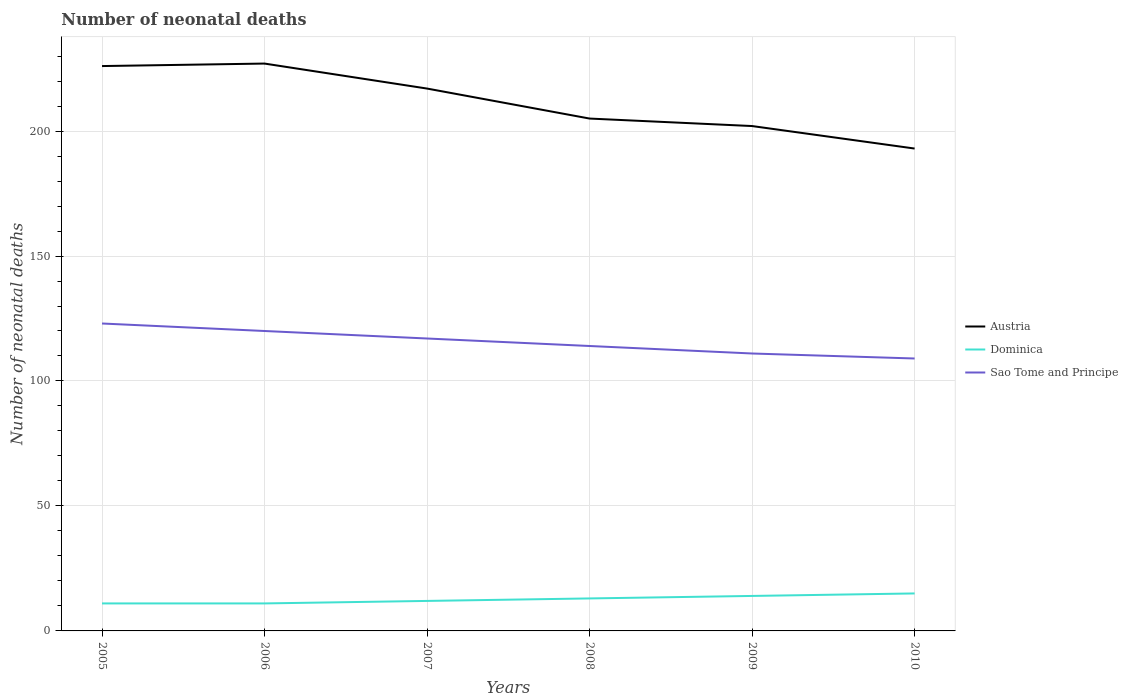Across all years, what is the maximum number of neonatal deaths in in Sao Tome and Principe?
Your answer should be compact. 109. In which year was the number of neonatal deaths in in Sao Tome and Principe maximum?
Offer a terse response. 2010. What is the total number of neonatal deaths in in Austria in the graph?
Your answer should be compact. 24. What is the difference between the highest and the second highest number of neonatal deaths in in Austria?
Your answer should be compact. 34. How many lines are there?
Your response must be concise. 3. How are the legend labels stacked?
Offer a very short reply. Vertical. What is the title of the graph?
Your answer should be very brief. Number of neonatal deaths. What is the label or title of the X-axis?
Keep it short and to the point. Years. What is the label or title of the Y-axis?
Your answer should be compact. Number of neonatal deaths. What is the Number of neonatal deaths in Austria in 2005?
Provide a short and direct response. 226. What is the Number of neonatal deaths of Sao Tome and Principe in 2005?
Your response must be concise. 123. What is the Number of neonatal deaths in Austria in 2006?
Provide a succinct answer. 227. What is the Number of neonatal deaths in Sao Tome and Principe in 2006?
Give a very brief answer. 120. What is the Number of neonatal deaths in Austria in 2007?
Make the answer very short. 217. What is the Number of neonatal deaths of Dominica in 2007?
Give a very brief answer. 12. What is the Number of neonatal deaths in Sao Tome and Principe in 2007?
Offer a terse response. 117. What is the Number of neonatal deaths of Austria in 2008?
Keep it short and to the point. 205. What is the Number of neonatal deaths in Sao Tome and Principe in 2008?
Your answer should be very brief. 114. What is the Number of neonatal deaths of Austria in 2009?
Provide a short and direct response. 202. What is the Number of neonatal deaths in Dominica in 2009?
Keep it short and to the point. 14. What is the Number of neonatal deaths of Sao Tome and Principe in 2009?
Offer a terse response. 111. What is the Number of neonatal deaths of Austria in 2010?
Ensure brevity in your answer.  193. What is the Number of neonatal deaths of Dominica in 2010?
Give a very brief answer. 15. What is the Number of neonatal deaths of Sao Tome and Principe in 2010?
Provide a succinct answer. 109. Across all years, what is the maximum Number of neonatal deaths of Austria?
Give a very brief answer. 227. Across all years, what is the maximum Number of neonatal deaths of Dominica?
Offer a terse response. 15. Across all years, what is the maximum Number of neonatal deaths of Sao Tome and Principe?
Ensure brevity in your answer.  123. Across all years, what is the minimum Number of neonatal deaths of Austria?
Make the answer very short. 193. Across all years, what is the minimum Number of neonatal deaths of Sao Tome and Principe?
Keep it short and to the point. 109. What is the total Number of neonatal deaths in Austria in the graph?
Offer a very short reply. 1270. What is the total Number of neonatal deaths of Dominica in the graph?
Offer a terse response. 76. What is the total Number of neonatal deaths in Sao Tome and Principe in the graph?
Provide a short and direct response. 694. What is the difference between the Number of neonatal deaths in Austria in 2005 and that in 2006?
Make the answer very short. -1. What is the difference between the Number of neonatal deaths in Dominica in 2005 and that in 2006?
Your answer should be very brief. 0. What is the difference between the Number of neonatal deaths in Sao Tome and Principe in 2005 and that in 2006?
Provide a short and direct response. 3. What is the difference between the Number of neonatal deaths in Austria in 2005 and that in 2007?
Provide a succinct answer. 9. What is the difference between the Number of neonatal deaths of Austria in 2005 and that in 2008?
Your answer should be compact. 21. What is the difference between the Number of neonatal deaths of Dominica in 2005 and that in 2008?
Offer a very short reply. -2. What is the difference between the Number of neonatal deaths in Sao Tome and Principe in 2005 and that in 2009?
Your answer should be compact. 12. What is the difference between the Number of neonatal deaths in Austria in 2005 and that in 2010?
Provide a short and direct response. 33. What is the difference between the Number of neonatal deaths of Dominica in 2005 and that in 2010?
Make the answer very short. -4. What is the difference between the Number of neonatal deaths in Sao Tome and Principe in 2005 and that in 2010?
Make the answer very short. 14. What is the difference between the Number of neonatal deaths of Austria in 2006 and that in 2008?
Your answer should be very brief. 22. What is the difference between the Number of neonatal deaths of Austria in 2006 and that in 2010?
Offer a very short reply. 34. What is the difference between the Number of neonatal deaths in Austria in 2007 and that in 2009?
Provide a succinct answer. 15. What is the difference between the Number of neonatal deaths of Sao Tome and Principe in 2007 and that in 2009?
Provide a short and direct response. 6. What is the difference between the Number of neonatal deaths in Dominica in 2007 and that in 2010?
Ensure brevity in your answer.  -3. What is the difference between the Number of neonatal deaths in Dominica in 2008 and that in 2009?
Ensure brevity in your answer.  -1. What is the difference between the Number of neonatal deaths in Austria in 2008 and that in 2010?
Ensure brevity in your answer.  12. What is the difference between the Number of neonatal deaths of Sao Tome and Principe in 2008 and that in 2010?
Keep it short and to the point. 5. What is the difference between the Number of neonatal deaths in Sao Tome and Principe in 2009 and that in 2010?
Offer a terse response. 2. What is the difference between the Number of neonatal deaths in Austria in 2005 and the Number of neonatal deaths in Dominica in 2006?
Offer a terse response. 215. What is the difference between the Number of neonatal deaths in Austria in 2005 and the Number of neonatal deaths in Sao Tome and Principe in 2006?
Offer a terse response. 106. What is the difference between the Number of neonatal deaths of Dominica in 2005 and the Number of neonatal deaths of Sao Tome and Principe in 2006?
Keep it short and to the point. -109. What is the difference between the Number of neonatal deaths of Austria in 2005 and the Number of neonatal deaths of Dominica in 2007?
Your answer should be very brief. 214. What is the difference between the Number of neonatal deaths of Austria in 2005 and the Number of neonatal deaths of Sao Tome and Principe in 2007?
Keep it short and to the point. 109. What is the difference between the Number of neonatal deaths of Dominica in 2005 and the Number of neonatal deaths of Sao Tome and Principe in 2007?
Offer a very short reply. -106. What is the difference between the Number of neonatal deaths of Austria in 2005 and the Number of neonatal deaths of Dominica in 2008?
Make the answer very short. 213. What is the difference between the Number of neonatal deaths of Austria in 2005 and the Number of neonatal deaths of Sao Tome and Principe in 2008?
Offer a very short reply. 112. What is the difference between the Number of neonatal deaths of Dominica in 2005 and the Number of neonatal deaths of Sao Tome and Principe in 2008?
Provide a succinct answer. -103. What is the difference between the Number of neonatal deaths of Austria in 2005 and the Number of neonatal deaths of Dominica in 2009?
Your answer should be very brief. 212. What is the difference between the Number of neonatal deaths in Austria in 2005 and the Number of neonatal deaths in Sao Tome and Principe in 2009?
Offer a very short reply. 115. What is the difference between the Number of neonatal deaths of Dominica in 2005 and the Number of neonatal deaths of Sao Tome and Principe in 2009?
Your response must be concise. -100. What is the difference between the Number of neonatal deaths of Austria in 2005 and the Number of neonatal deaths of Dominica in 2010?
Your answer should be compact. 211. What is the difference between the Number of neonatal deaths of Austria in 2005 and the Number of neonatal deaths of Sao Tome and Principe in 2010?
Your answer should be very brief. 117. What is the difference between the Number of neonatal deaths of Dominica in 2005 and the Number of neonatal deaths of Sao Tome and Principe in 2010?
Provide a succinct answer. -98. What is the difference between the Number of neonatal deaths in Austria in 2006 and the Number of neonatal deaths in Dominica in 2007?
Offer a terse response. 215. What is the difference between the Number of neonatal deaths in Austria in 2006 and the Number of neonatal deaths in Sao Tome and Principe in 2007?
Make the answer very short. 110. What is the difference between the Number of neonatal deaths of Dominica in 2006 and the Number of neonatal deaths of Sao Tome and Principe in 2007?
Offer a terse response. -106. What is the difference between the Number of neonatal deaths of Austria in 2006 and the Number of neonatal deaths of Dominica in 2008?
Keep it short and to the point. 214. What is the difference between the Number of neonatal deaths in Austria in 2006 and the Number of neonatal deaths in Sao Tome and Principe in 2008?
Make the answer very short. 113. What is the difference between the Number of neonatal deaths of Dominica in 2006 and the Number of neonatal deaths of Sao Tome and Principe in 2008?
Offer a very short reply. -103. What is the difference between the Number of neonatal deaths of Austria in 2006 and the Number of neonatal deaths of Dominica in 2009?
Offer a very short reply. 213. What is the difference between the Number of neonatal deaths in Austria in 2006 and the Number of neonatal deaths in Sao Tome and Principe in 2009?
Offer a very short reply. 116. What is the difference between the Number of neonatal deaths in Dominica in 2006 and the Number of neonatal deaths in Sao Tome and Principe in 2009?
Make the answer very short. -100. What is the difference between the Number of neonatal deaths of Austria in 2006 and the Number of neonatal deaths of Dominica in 2010?
Your response must be concise. 212. What is the difference between the Number of neonatal deaths of Austria in 2006 and the Number of neonatal deaths of Sao Tome and Principe in 2010?
Your response must be concise. 118. What is the difference between the Number of neonatal deaths in Dominica in 2006 and the Number of neonatal deaths in Sao Tome and Principe in 2010?
Offer a terse response. -98. What is the difference between the Number of neonatal deaths in Austria in 2007 and the Number of neonatal deaths in Dominica in 2008?
Give a very brief answer. 204. What is the difference between the Number of neonatal deaths of Austria in 2007 and the Number of neonatal deaths of Sao Tome and Principe in 2008?
Keep it short and to the point. 103. What is the difference between the Number of neonatal deaths in Dominica in 2007 and the Number of neonatal deaths in Sao Tome and Principe in 2008?
Provide a short and direct response. -102. What is the difference between the Number of neonatal deaths in Austria in 2007 and the Number of neonatal deaths in Dominica in 2009?
Your response must be concise. 203. What is the difference between the Number of neonatal deaths of Austria in 2007 and the Number of neonatal deaths of Sao Tome and Principe in 2009?
Your answer should be very brief. 106. What is the difference between the Number of neonatal deaths of Dominica in 2007 and the Number of neonatal deaths of Sao Tome and Principe in 2009?
Give a very brief answer. -99. What is the difference between the Number of neonatal deaths in Austria in 2007 and the Number of neonatal deaths in Dominica in 2010?
Provide a short and direct response. 202. What is the difference between the Number of neonatal deaths of Austria in 2007 and the Number of neonatal deaths of Sao Tome and Principe in 2010?
Your answer should be very brief. 108. What is the difference between the Number of neonatal deaths in Dominica in 2007 and the Number of neonatal deaths in Sao Tome and Principe in 2010?
Your answer should be very brief. -97. What is the difference between the Number of neonatal deaths of Austria in 2008 and the Number of neonatal deaths of Dominica in 2009?
Give a very brief answer. 191. What is the difference between the Number of neonatal deaths of Austria in 2008 and the Number of neonatal deaths of Sao Tome and Principe in 2009?
Offer a terse response. 94. What is the difference between the Number of neonatal deaths of Dominica in 2008 and the Number of neonatal deaths of Sao Tome and Principe in 2009?
Your response must be concise. -98. What is the difference between the Number of neonatal deaths of Austria in 2008 and the Number of neonatal deaths of Dominica in 2010?
Your response must be concise. 190. What is the difference between the Number of neonatal deaths of Austria in 2008 and the Number of neonatal deaths of Sao Tome and Principe in 2010?
Ensure brevity in your answer.  96. What is the difference between the Number of neonatal deaths in Dominica in 2008 and the Number of neonatal deaths in Sao Tome and Principe in 2010?
Offer a terse response. -96. What is the difference between the Number of neonatal deaths of Austria in 2009 and the Number of neonatal deaths of Dominica in 2010?
Make the answer very short. 187. What is the difference between the Number of neonatal deaths of Austria in 2009 and the Number of neonatal deaths of Sao Tome and Principe in 2010?
Ensure brevity in your answer.  93. What is the difference between the Number of neonatal deaths of Dominica in 2009 and the Number of neonatal deaths of Sao Tome and Principe in 2010?
Your response must be concise. -95. What is the average Number of neonatal deaths of Austria per year?
Offer a terse response. 211.67. What is the average Number of neonatal deaths in Dominica per year?
Your response must be concise. 12.67. What is the average Number of neonatal deaths of Sao Tome and Principe per year?
Keep it short and to the point. 115.67. In the year 2005, what is the difference between the Number of neonatal deaths of Austria and Number of neonatal deaths of Dominica?
Keep it short and to the point. 215. In the year 2005, what is the difference between the Number of neonatal deaths of Austria and Number of neonatal deaths of Sao Tome and Principe?
Offer a terse response. 103. In the year 2005, what is the difference between the Number of neonatal deaths in Dominica and Number of neonatal deaths in Sao Tome and Principe?
Offer a very short reply. -112. In the year 2006, what is the difference between the Number of neonatal deaths of Austria and Number of neonatal deaths of Dominica?
Your response must be concise. 216. In the year 2006, what is the difference between the Number of neonatal deaths of Austria and Number of neonatal deaths of Sao Tome and Principe?
Give a very brief answer. 107. In the year 2006, what is the difference between the Number of neonatal deaths of Dominica and Number of neonatal deaths of Sao Tome and Principe?
Give a very brief answer. -109. In the year 2007, what is the difference between the Number of neonatal deaths of Austria and Number of neonatal deaths of Dominica?
Your response must be concise. 205. In the year 2007, what is the difference between the Number of neonatal deaths of Dominica and Number of neonatal deaths of Sao Tome and Principe?
Make the answer very short. -105. In the year 2008, what is the difference between the Number of neonatal deaths in Austria and Number of neonatal deaths in Dominica?
Your answer should be very brief. 192. In the year 2008, what is the difference between the Number of neonatal deaths in Austria and Number of neonatal deaths in Sao Tome and Principe?
Provide a short and direct response. 91. In the year 2008, what is the difference between the Number of neonatal deaths in Dominica and Number of neonatal deaths in Sao Tome and Principe?
Offer a very short reply. -101. In the year 2009, what is the difference between the Number of neonatal deaths of Austria and Number of neonatal deaths of Dominica?
Provide a short and direct response. 188. In the year 2009, what is the difference between the Number of neonatal deaths in Austria and Number of neonatal deaths in Sao Tome and Principe?
Your answer should be very brief. 91. In the year 2009, what is the difference between the Number of neonatal deaths in Dominica and Number of neonatal deaths in Sao Tome and Principe?
Make the answer very short. -97. In the year 2010, what is the difference between the Number of neonatal deaths in Austria and Number of neonatal deaths in Dominica?
Ensure brevity in your answer.  178. In the year 2010, what is the difference between the Number of neonatal deaths of Dominica and Number of neonatal deaths of Sao Tome and Principe?
Ensure brevity in your answer.  -94. What is the ratio of the Number of neonatal deaths of Sao Tome and Principe in 2005 to that in 2006?
Provide a succinct answer. 1.02. What is the ratio of the Number of neonatal deaths in Austria in 2005 to that in 2007?
Your response must be concise. 1.04. What is the ratio of the Number of neonatal deaths in Sao Tome and Principe in 2005 to that in 2007?
Give a very brief answer. 1.05. What is the ratio of the Number of neonatal deaths of Austria in 2005 to that in 2008?
Give a very brief answer. 1.1. What is the ratio of the Number of neonatal deaths in Dominica in 2005 to that in 2008?
Offer a terse response. 0.85. What is the ratio of the Number of neonatal deaths of Sao Tome and Principe in 2005 to that in 2008?
Your response must be concise. 1.08. What is the ratio of the Number of neonatal deaths in Austria in 2005 to that in 2009?
Ensure brevity in your answer.  1.12. What is the ratio of the Number of neonatal deaths in Dominica in 2005 to that in 2009?
Your response must be concise. 0.79. What is the ratio of the Number of neonatal deaths in Sao Tome and Principe in 2005 to that in 2009?
Provide a succinct answer. 1.11. What is the ratio of the Number of neonatal deaths of Austria in 2005 to that in 2010?
Give a very brief answer. 1.17. What is the ratio of the Number of neonatal deaths of Dominica in 2005 to that in 2010?
Offer a terse response. 0.73. What is the ratio of the Number of neonatal deaths of Sao Tome and Principe in 2005 to that in 2010?
Your answer should be very brief. 1.13. What is the ratio of the Number of neonatal deaths of Austria in 2006 to that in 2007?
Provide a succinct answer. 1.05. What is the ratio of the Number of neonatal deaths in Sao Tome and Principe in 2006 to that in 2007?
Give a very brief answer. 1.03. What is the ratio of the Number of neonatal deaths of Austria in 2006 to that in 2008?
Keep it short and to the point. 1.11. What is the ratio of the Number of neonatal deaths of Dominica in 2006 to that in 2008?
Provide a succinct answer. 0.85. What is the ratio of the Number of neonatal deaths in Sao Tome and Principe in 2006 to that in 2008?
Make the answer very short. 1.05. What is the ratio of the Number of neonatal deaths in Austria in 2006 to that in 2009?
Ensure brevity in your answer.  1.12. What is the ratio of the Number of neonatal deaths in Dominica in 2006 to that in 2009?
Give a very brief answer. 0.79. What is the ratio of the Number of neonatal deaths of Sao Tome and Principe in 2006 to that in 2009?
Keep it short and to the point. 1.08. What is the ratio of the Number of neonatal deaths of Austria in 2006 to that in 2010?
Ensure brevity in your answer.  1.18. What is the ratio of the Number of neonatal deaths of Dominica in 2006 to that in 2010?
Provide a succinct answer. 0.73. What is the ratio of the Number of neonatal deaths in Sao Tome and Principe in 2006 to that in 2010?
Provide a short and direct response. 1.1. What is the ratio of the Number of neonatal deaths of Austria in 2007 to that in 2008?
Ensure brevity in your answer.  1.06. What is the ratio of the Number of neonatal deaths of Dominica in 2007 to that in 2008?
Your answer should be compact. 0.92. What is the ratio of the Number of neonatal deaths in Sao Tome and Principe in 2007 to that in 2008?
Make the answer very short. 1.03. What is the ratio of the Number of neonatal deaths of Austria in 2007 to that in 2009?
Give a very brief answer. 1.07. What is the ratio of the Number of neonatal deaths in Dominica in 2007 to that in 2009?
Offer a terse response. 0.86. What is the ratio of the Number of neonatal deaths of Sao Tome and Principe in 2007 to that in 2009?
Offer a very short reply. 1.05. What is the ratio of the Number of neonatal deaths in Austria in 2007 to that in 2010?
Give a very brief answer. 1.12. What is the ratio of the Number of neonatal deaths in Sao Tome and Principe in 2007 to that in 2010?
Keep it short and to the point. 1.07. What is the ratio of the Number of neonatal deaths of Austria in 2008 to that in 2009?
Your response must be concise. 1.01. What is the ratio of the Number of neonatal deaths of Sao Tome and Principe in 2008 to that in 2009?
Offer a terse response. 1.03. What is the ratio of the Number of neonatal deaths of Austria in 2008 to that in 2010?
Provide a succinct answer. 1.06. What is the ratio of the Number of neonatal deaths of Dominica in 2008 to that in 2010?
Offer a terse response. 0.87. What is the ratio of the Number of neonatal deaths in Sao Tome and Principe in 2008 to that in 2010?
Offer a terse response. 1.05. What is the ratio of the Number of neonatal deaths in Austria in 2009 to that in 2010?
Offer a terse response. 1.05. What is the ratio of the Number of neonatal deaths of Sao Tome and Principe in 2009 to that in 2010?
Give a very brief answer. 1.02. What is the difference between the highest and the second highest Number of neonatal deaths of Austria?
Give a very brief answer. 1. What is the difference between the highest and the second highest Number of neonatal deaths in Sao Tome and Principe?
Make the answer very short. 3. What is the difference between the highest and the lowest Number of neonatal deaths of Austria?
Your response must be concise. 34. What is the difference between the highest and the lowest Number of neonatal deaths in Sao Tome and Principe?
Ensure brevity in your answer.  14. 